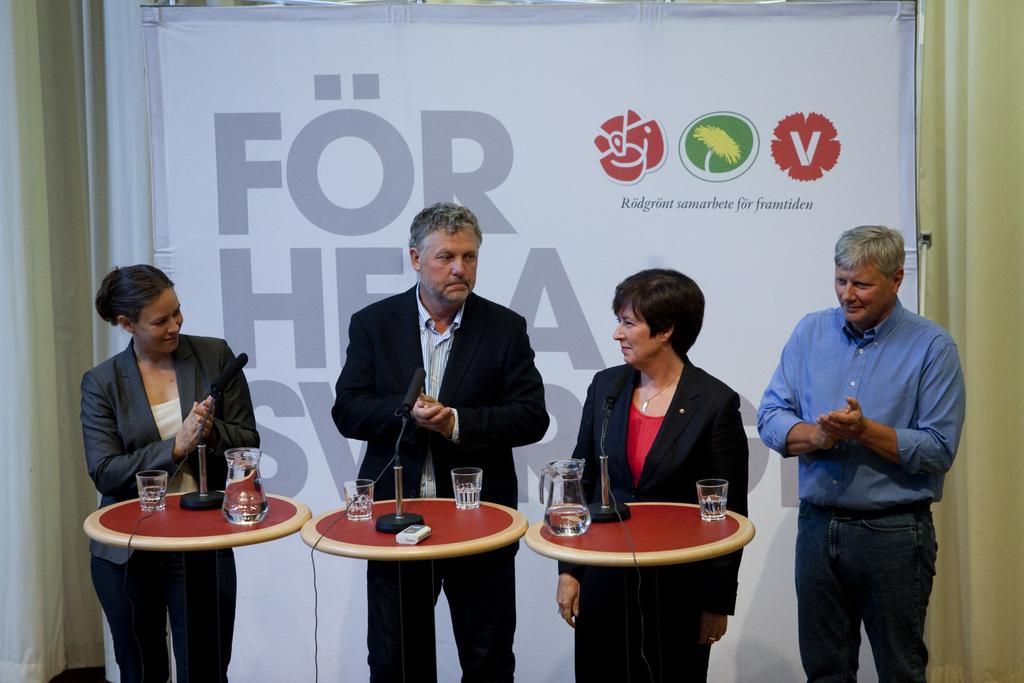How many people are present in the image? There are four people standing in the image. What is located behind the people? There is a banner behind the people. What is in front of the people? There is a table in front of the people. What items can be seen on the table? There is a water glass, a water jar, and a microphone on the table. Where are the chickens located in the image? There are no chickens present in the image. Can you tell me how many boats are in the harbor in the image? There is no harbor or boats present in the image. 